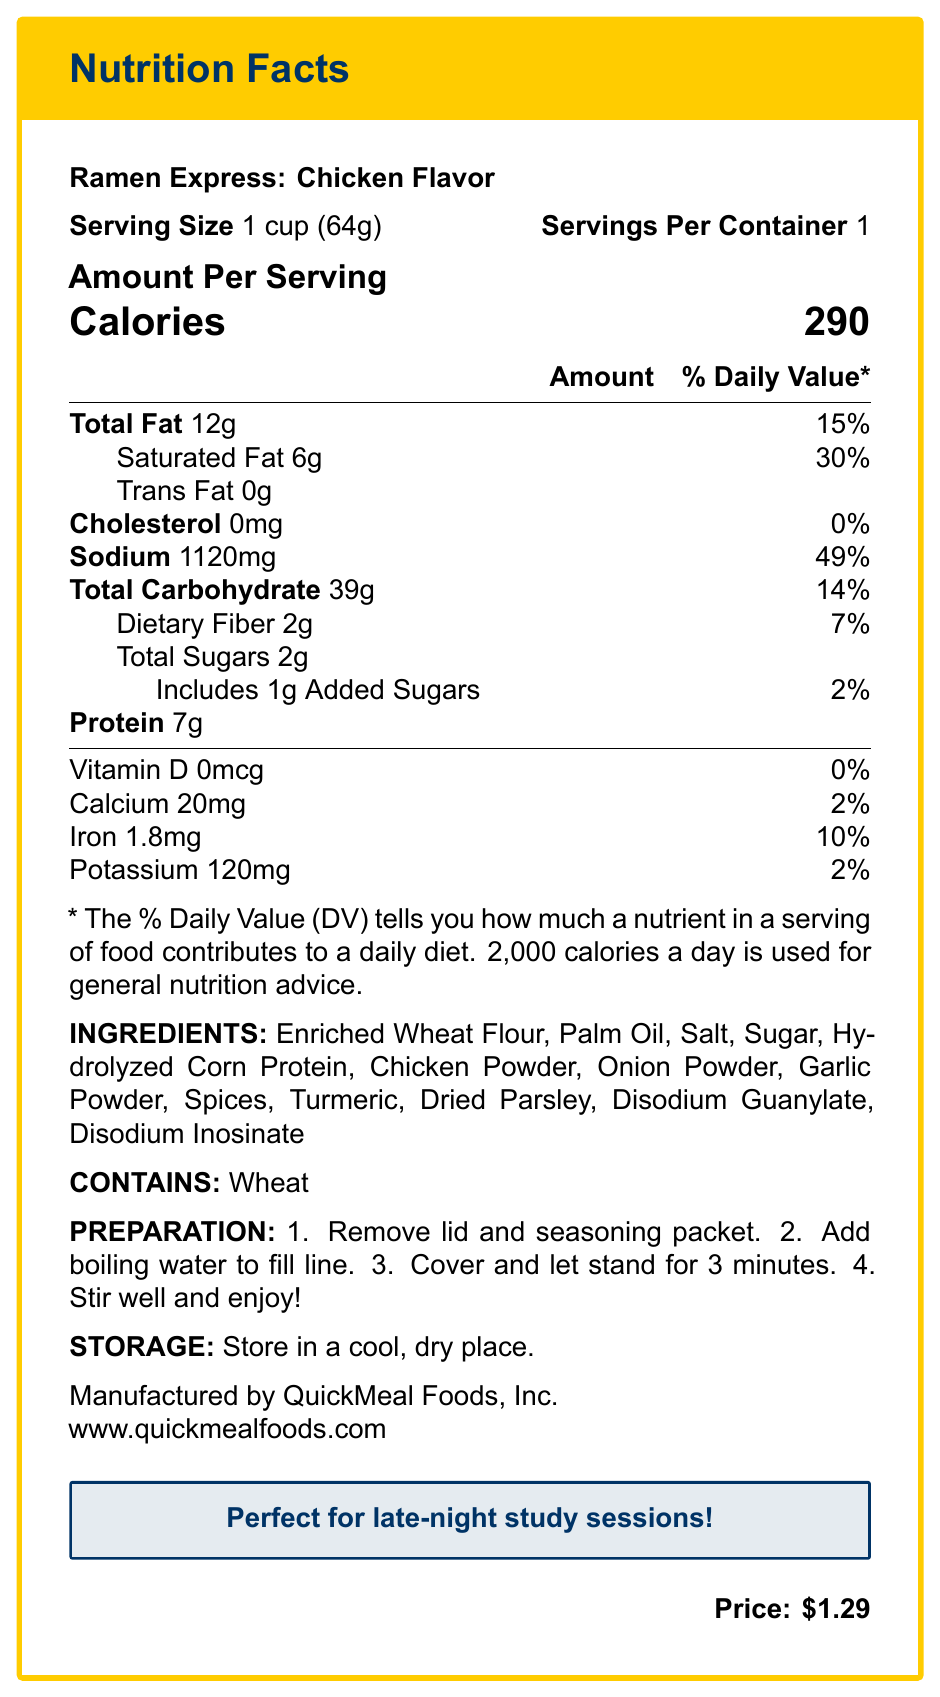what is the serving size of Ramen Express: Chicken Flavor? The serving size is stated in the document as "Serving Size: 1 cup (64g)."
Answer: 1 cup (64g) how many calories are in one serving? The document specifies the calorie count as 290 under "Amount Per Serving."
Answer: 290 how much sodium is in one serving? The sodium content is listed as 1120mg, found in the "Sodium" section.
Answer: 1120 mg what is the percentage daily value of saturated fat? The daily value percentage for saturated fat is listed as 30%.
Answer: 30% how many grams of dietary fiber are in a serving? The dietary fiber content is listed as 2g under the "Dietary Fiber" section.
Answer: 2g how much protein is in one serving? The document specifies the protein content as 7g under "Amount Per Serving."
Answer: 7g what vitamins are listed in the nutrition label? The only vitamin listed is Vitamin D with an amount of 0mcg and a daily value of 0%.
Answer: Vitamin D what is the price of the Ramen Express: Chicken Flavor? The price is stated at the bottom of the document as "$1.29."
Answer: $1.29 Multiple-choice: what is the main ingredient listed?
A. Palm Oil
B. Enriched Wheat Flour
C. Chicken Powder
D. Salt The first ingredient listed is "Enriched Wheat Flour," making it the main ingredient.
Answer: B Multiple-choice: what is the daily value percentage of iron in the product?
I. 2%
II. 10%
III. 15%
IV. 20% The document lists the daily value percentage of iron as 10%.
Answer: II Yes/No: does the product contain gluten? The product contains "Enriched Wheat Flour," which includes gluten, and it explicitly says "Contains Wheat."
Answer: Yes Summary: describe the main idea of the document. The document provides a comprehensive overview of the nutritional content, ingredients, preparation instructions, and other relevant details for a specific instant noodle product commonly purchased by college students.
Answer: It is the Nutrition Facts label for Ramen Express: Chicken Flavor, a microwaveable instant noodle cup. It includes nutritional information per serving, ingredient list, allergens, preparation instructions, storage instructions, manufacturer details, and price. how often is the product recommended for those managing cholesterol intake? The document does not provide any recommendations for frequency of consumption, especially related to managing cholesterol intake.
Answer: Cannot be determined 